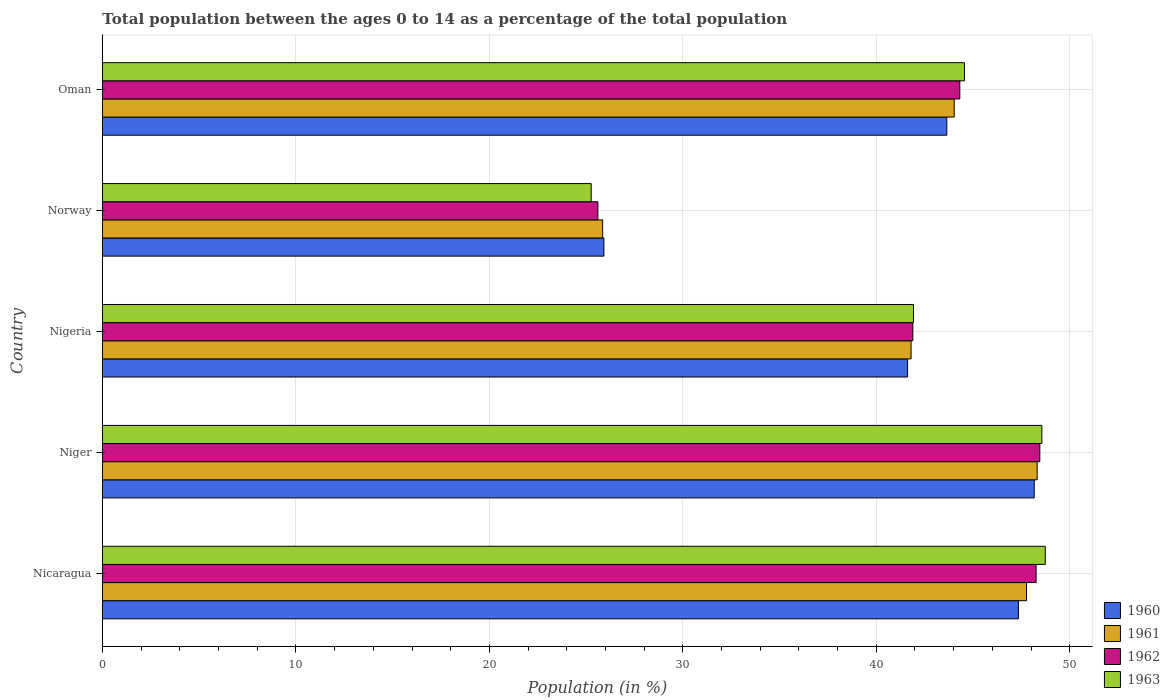How many different coloured bars are there?
Provide a short and direct response. 4. How many groups of bars are there?
Your response must be concise. 5. Are the number of bars per tick equal to the number of legend labels?
Your response must be concise. Yes. What is the label of the 2nd group of bars from the top?
Your answer should be very brief. Norway. What is the percentage of the population ages 0 to 14 in 1960 in Oman?
Ensure brevity in your answer.  43.65. Across all countries, what is the maximum percentage of the population ages 0 to 14 in 1963?
Give a very brief answer. 48.74. Across all countries, what is the minimum percentage of the population ages 0 to 14 in 1961?
Provide a succinct answer. 25.86. In which country was the percentage of the population ages 0 to 14 in 1963 maximum?
Give a very brief answer. Nicaragua. In which country was the percentage of the population ages 0 to 14 in 1962 minimum?
Offer a very short reply. Norway. What is the total percentage of the population ages 0 to 14 in 1960 in the graph?
Give a very brief answer. 206.69. What is the difference between the percentage of the population ages 0 to 14 in 1961 in Niger and that in Nigeria?
Offer a terse response. 6.52. What is the difference between the percentage of the population ages 0 to 14 in 1963 in Oman and the percentage of the population ages 0 to 14 in 1960 in Norway?
Ensure brevity in your answer.  18.64. What is the average percentage of the population ages 0 to 14 in 1961 per country?
Give a very brief answer. 41.55. What is the difference between the percentage of the population ages 0 to 14 in 1962 and percentage of the population ages 0 to 14 in 1961 in Oman?
Ensure brevity in your answer.  0.29. In how many countries, is the percentage of the population ages 0 to 14 in 1961 greater than 30 ?
Your answer should be very brief. 4. What is the ratio of the percentage of the population ages 0 to 14 in 1960 in Norway to that in Oman?
Provide a short and direct response. 0.59. Is the difference between the percentage of the population ages 0 to 14 in 1962 in Niger and Nigeria greater than the difference between the percentage of the population ages 0 to 14 in 1961 in Niger and Nigeria?
Ensure brevity in your answer.  Yes. What is the difference between the highest and the second highest percentage of the population ages 0 to 14 in 1963?
Provide a short and direct response. 0.18. What is the difference between the highest and the lowest percentage of the population ages 0 to 14 in 1962?
Give a very brief answer. 22.84. In how many countries, is the percentage of the population ages 0 to 14 in 1960 greater than the average percentage of the population ages 0 to 14 in 1960 taken over all countries?
Ensure brevity in your answer.  4. How many bars are there?
Offer a very short reply. 20. How many countries are there in the graph?
Give a very brief answer. 5. Does the graph contain any zero values?
Provide a short and direct response. No. Does the graph contain grids?
Your answer should be compact. Yes. How many legend labels are there?
Provide a succinct answer. 4. What is the title of the graph?
Ensure brevity in your answer.  Total population between the ages 0 to 14 as a percentage of the total population. What is the label or title of the X-axis?
Make the answer very short. Population (in %). What is the label or title of the Y-axis?
Your answer should be compact. Country. What is the Population (in %) of 1960 in Nicaragua?
Make the answer very short. 47.35. What is the Population (in %) of 1961 in Nicaragua?
Offer a terse response. 47.77. What is the Population (in %) in 1962 in Nicaragua?
Offer a terse response. 48.26. What is the Population (in %) in 1963 in Nicaragua?
Offer a terse response. 48.74. What is the Population (in %) in 1960 in Niger?
Offer a very short reply. 48.16. What is the Population (in %) in 1961 in Niger?
Give a very brief answer. 48.32. What is the Population (in %) in 1962 in Niger?
Offer a very short reply. 48.45. What is the Population (in %) in 1963 in Niger?
Offer a very short reply. 48.56. What is the Population (in %) of 1960 in Nigeria?
Provide a succinct answer. 41.62. What is the Population (in %) in 1961 in Nigeria?
Your answer should be compact. 41.8. What is the Population (in %) of 1962 in Nigeria?
Your answer should be very brief. 41.89. What is the Population (in %) in 1963 in Nigeria?
Give a very brief answer. 41.92. What is the Population (in %) of 1960 in Norway?
Make the answer very short. 25.92. What is the Population (in %) in 1961 in Norway?
Ensure brevity in your answer.  25.86. What is the Population (in %) in 1962 in Norway?
Provide a short and direct response. 25.61. What is the Population (in %) of 1963 in Norway?
Your response must be concise. 25.26. What is the Population (in %) in 1960 in Oman?
Ensure brevity in your answer.  43.65. What is the Population (in %) in 1961 in Oman?
Offer a terse response. 44.03. What is the Population (in %) in 1962 in Oman?
Offer a terse response. 44.32. What is the Population (in %) of 1963 in Oman?
Your answer should be compact. 44.56. Across all countries, what is the maximum Population (in %) in 1960?
Provide a short and direct response. 48.16. Across all countries, what is the maximum Population (in %) of 1961?
Offer a very short reply. 48.32. Across all countries, what is the maximum Population (in %) of 1962?
Provide a succinct answer. 48.45. Across all countries, what is the maximum Population (in %) in 1963?
Your response must be concise. 48.74. Across all countries, what is the minimum Population (in %) in 1960?
Provide a short and direct response. 25.92. Across all countries, what is the minimum Population (in %) of 1961?
Your answer should be very brief. 25.86. Across all countries, what is the minimum Population (in %) in 1962?
Keep it short and to the point. 25.61. Across all countries, what is the minimum Population (in %) of 1963?
Ensure brevity in your answer.  25.26. What is the total Population (in %) of 1960 in the graph?
Offer a very short reply. 206.69. What is the total Population (in %) in 1961 in the graph?
Give a very brief answer. 207.76. What is the total Population (in %) in 1962 in the graph?
Keep it short and to the point. 208.53. What is the total Population (in %) in 1963 in the graph?
Keep it short and to the point. 209.04. What is the difference between the Population (in %) of 1960 in Nicaragua and that in Niger?
Provide a short and direct response. -0.82. What is the difference between the Population (in %) of 1961 in Nicaragua and that in Niger?
Keep it short and to the point. -0.55. What is the difference between the Population (in %) of 1962 in Nicaragua and that in Niger?
Offer a terse response. -0.19. What is the difference between the Population (in %) in 1963 in Nicaragua and that in Niger?
Make the answer very short. 0.18. What is the difference between the Population (in %) in 1960 in Nicaragua and that in Nigeria?
Provide a short and direct response. 5.73. What is the difference between the Population (in %) of 1961 in Nicaragua and that in Nigeria?
Offer a very short reply. 5.97. What is the difference between the Population (in %) in 1962 in Nicaragua and that in Nigeria?
Offer a very short reply. 6.37. What is the difference between the Population (in %) of 1963 in Nicaragua and that in Nigeria?
Offer a terse response. 6.81. What is the difference between the Population (in %) in 1960 in Nicaragua and that in Norway?
Provide a succinct answer. 21.43. What is the difference between the Population (in %) in 1961 in Nicaragua and that in Norway?
Keep it short and to the point. 21.91. What is the difference between the Population (in %) of 1962 in Nicaragua and that in Norway?
Your response must be concise. 22.65. What is the difference between the Population (in %) in 1963 in Nicaragua and that in Norway?
Your answer should be compact. 23.47. What is the difference between the Population (in %) in 1960 in Nicaragua and that in Oman?
Offer a terse response. 3.7. What is the difference between the Population (in %) of 1961 in Nicaragua and that in Oman?
Your answer should be very brief. 3.74. What is the difference between the Population (in %) of 1962 in Nicaragua and that in Oman?
Your answer should be very brief. 3.94. What is the difference between the Population (in %) in 1963 in Nicaragua and that in Oman?
Ensure brevity in your answer.  4.18. What is the difference between the Population (in %) of 1960 in Niger and that in Nigeria?
Provide a short and direct response. 6.54. What is the difference between the Population (in %) in 1961 in Niger and that in Nigeria?
Offer a terse response. 6.52. What is the difference between the Population (in %) in 1962 in Niger and that in Nigeria?
Give a very brief answer. 6.57. What is the difference between the Population (in %) in 1963 in Niger and that in Nigeria?
Keep it short and to the point. 6.64. What is the difference between the Population (in %) in 1960 in Niger and that in Norway?
Ensure brevity in your answer.  22.24. What is the difference between the Population (in %) of 1961 in Niger and that in Norway?
Your response must be concise. 22.46. What is the difference between the Population (in %) of 1962 in Niger and that in Norway?
Offer a terse response. 22.84. What is the difference between the Population (in %) in 1963 in Niger and that in Norway?
Offer a very short reply. 23.3. What is the difference between the Population (in %) in 1960 in Niger and that in Oman?
Give a very brief answer. 4.52. What is the difference between the Population (in %) of 1961 in Niger and that in Oman?
Provide a short and direct response. 4.29. What is the difference between the Population (in %) in 1962 in Niger and that in Oman?
Provide a succinct answer. 4.14. What is the difference between the Population (in %) of 1963 in Niger and that in Oman?
Offer a very short reply. 4. What is the difference between the Population (in %) of 1960 in Nigeria and that in Norway?
Offer a terse response. 15.7. What is the difference between the Population (in %) of 1961 in Nigeria and that in Norway?
Offer a terse response. 15.94. What is the difference between the Population (in %) in 1962 in Nigeria and that in Norway?
Make the answer very short. 16.28. What is the difference between the Population (in %) of 1963 in Nigeria and that in Norway?
Provide a succinct answer. 16.66. What is the difference between the Population (in %) in 1960 in Nigeria and that in Oman?
Your answer should be very brief. -2.03. What is the difference between the Population (in %) in 1961 in Nigeria and that in Oman?
Your answer should be compact. -2.23. What is the difference between the Population (in %) in 1962 in Nigeria and that in Oman?
Make the answer very short. -2.43. What is the difference between the Population (in %) in 1963 in Nigeria and that in Oman?
Offer a terse response. -2.63. What is the difference between the Population (in %) of 1960 in Norway and that in Oman?
Ensure brevity in your answer.  -17.73. What is the difference between the Population (in %) of 1961 in Norway and that in Oman?
Your answer should be compact. -18.17. What is the difference between the Population (in %) of 1962 in Norway and that in Oman?
Make the answer very short. -18.71. What is the difference between the Population (in %) of 1963 in Norway and that in Oman?
Offer a terse response. -19.3. What is the difference between the Population (in %) of 1960 in Nicaragua and the Population (in %) of 1961 in Niger?
Keep it short and to the point. -0.97. What is the difference between the Population (in %) of 1960 in Nicaragua and the Population (in %) of 1962 in Niger?
Your response must be concise. -1.11. What is the difference between the Population (in %) in 1960 in Nicaragua and the Population (in %) in 1963 in Niger?
Your response must be concise. -1.21. What is the difference between the Population (in %) in 1961 in Nicaragua and the Population (in %) in 1962 in Niger?
Your answer should be very brief. -0.69. What is the difference between the Population (in %) of 1961 in Nicaragua and the Population (in %) of 1963 in Niger?
Your response must be concise. -0.79. What is the difference between the Population (in %) of 1962 in Nicaragua and the Population (in %) of 1963 in Niger?
Your response must be concise. -0.3. What is the difference between the Population (in %) in 1960 in Nicaragua and the Population (in %) in 1961 in Nigeria?
Ensure brevity in your answer.  5.55. What is the difference between the Population (in %) in 1960 in Nicaragua and the Population (in %) in 1962 in Nigeria?
Keep it short and to the point. 5.46. What is the difference between the Population (in %) in 1960 in Nicaragua and the Population (in %) in 1963 in Nigeria?
Provide a short and direct response. 5.42. What is the difference between the Population (in %) of 1961 in Nicaragua and the Population (in %) of 1962 in Nigeria?
Provide a short and direct response. 5.88. What is the difference between the Population (in %) of 1961 in Nicaragua and the Population (in %) of 1963 in Nigeria?
Ensure brevity in your answer.  5.84. What is the difference between the Population (in %) of 1962 in Nicaragua and the Population (in %) of 1963 in Nigeria?
Your answer should be very brief. 6.34. What is the difference between the Population (in %) in 1960 in Nicaragua and the Population (in %) in 1961 in Norway?
Keep it short and to the point. 21.49. What is the difference between the Population (in %) of 1960 in Nicaragua and the Population (in %) of 1962 in Norway?
Offer a terse response. 21.74. What is the difference between the Population (in %) in 1960 in Nicaragua and the Population (in %) in 1963 in Norway?
Provide a succinct answer. 22.08. What is the difference between the Population (in %) in 1961 in Nicaragua and the Population (in %) in 1962 in Norway?
Keep it short and to the point. 22.16. What is the difference between the Population (in %) of 1961 in Nicaragua and the Population (in %) of 1963 in Norway?
Provide a short and direct response. 22.5. What is the difference between the Population (in %) of 1962 in Nicaragua and the Population (in %) of 1963 in Norway?
Provide a succinct answer. 23. What is the difference between the Population (in %) of 1960 in Nicaragua and the Population (in %) of 1961 in Oman?
Offer a very short reply. 3.32. What is the difference between the Population (in %) of 1960 in Nicaragua and the Population (in %) of 1962 in Oman?
Your response must be concise. 3.03. What is the difference between the Population (in %) of 1960 in Nicaragua and the Population (in %) of 1963 in Oman?
Ensure brevity in your answer.  2.79. What is the difference between the Population (in %) of 1961 in Nicaragua and the Population (in %) of 1962 in Oman?
Ensure brevity in your answer.  3.45. What is the difference between the Population (in %) of 1961 in Nicaragua and the Population (in %) of 1963 in Oman?
Your response must be concise. 3.21. What is the difference between the Population (in %) of 1962 in Nicaragua and the Population (in %) of 1963 in Oman?
Your answer should be compact. 3.7. What is the difference between the Population (in %) of 1960 in Niger and the Population (in %) of 1961 in Nigeria?
Your answer should be compact. 6.37. What is the difference between the Population (in %) in 1960 in Niger and the Population (in %) in 1962 in Nigeria?
Make the answer very short. 6.28. What is the difference between the Population (in %) in 1960 in Niger and the Population (in %) in 1963 in Nigeria?
Provide a succinct answer. 6.24. What is the difference between the Population (in %) of 1961 in Niger and the Population (in %) of 1962 in Nigeria?
Ensure brevity in your answer.  6.43. What is the difference between the Population (in %) of 1961 in Niger and the Population (in %) of 1963 in Nigeria?
Ensure brevity in your answer.  6.39. What is the difference between the Population (in %) of 1962 in Niger and the Population (in %) of 1963 in Nigeria?
Ensure brevity in your answer.  6.53. What is the difference between the Population (in %) in 1960 in Niger and the Population (in %) in 1961 in Norway?
Provide a short and direct response. 22.31. What is the difference between the Population (in %) in 1960 in Niger and the Population (in %) in 1962 in Norway?
Provide a succinct answer. 22.55. What is the difference between the Population (in %) of 1960 in Niger and the Population (in %) of 1963 in Norway?
Give a very brief answer. 22.9. What is the difference between the Population (in %) in 1961 in Niger and the Population (in %) in 1962 in Norway?
Ensure brevity in your answer.  22.71. What is the difference between the Population (in %) in 1961 in Niger and the Population (in %) in 1963 in Norway?
Give a very brief answer. 23.05. What is the difference between the Population (in %) in 1962 in Niger and the Population (in %) in 1963 in Norway?
Your answer should be very brief. 23.19. What is the difference between the Population (in %) of 1960 in Niger and the Population (in %) of 1961 in Oman?
Your answer should be compact. 4.14. What is the difference between the Population (in %) of 1960 in Niger and the Population (in %) of 1962 in Oman?
Provide a succinct answer. 3.85. What is the difference between the Population (in %) in 1960 in Niger and the Population (in %) in 1963 in Oman?
Give a very brief answer. 3.61. What is the difference between the Population (in %) in 1961 in Niger and the Population (in %) in 1962 in Oman?
Offer a very short reply. 4. What is the difference between the Population (in %) in 1961 in Niger and the Population (in %) in 1963 in Oman?
Your response must be concise. 3.76. What is the difference between the Population (in %) of 1962 in Niger and the Population (in %) of 1963 in Oman?
Your answer should be very brief. 3.9. What is the difference between the Population (in %) of 1960 in Nigeria and the Population (in %) of 1961 in Norway?
Provide a succinct answer. 15.76. What is the difference between the Population (in %) in 1960 in Nigeria and the Population (in %) in 1962 in Norway?
Your answer should be compact. 16.01. What is the difference between the Population (in %) in 1960 in Nigeria and the Population (in %) in 1963 in Norway?
Your answer should be very brief. 16.36. What is the difference between the Population (in %) in 1961 in Nigeria and the Population (in %) in 1962 in Norway?
Ensure brevity in your answer.  16.19. What is the difference between the Population (in %) in 1961 in Nigeria and the Population (in %) in 1963 in Norway?
Give a very brief answer. 16.54. What is the difference between the Population (in %) of 1962 in Nigeria and the Population (in %) of 1963 in Norway?
Make the answer very short. 16.63. What is the difference between the Population (in %) in 1960 in Nigeria and the Population (in %) in 1961 in Oman?
Offer a very short reply. -2.41. What is the difference between the Population (in %) in 1960 in Nigeria and the Population (in %) in 1962 in Oman?
Give a very brief answer. -2.7. What is the difference between the Population (in %) in 1960 in Nigeria and the Population (in %) in 1963 in Oman?
Make the answer very short. -2.94. What is the difference between the Population (in %) in 1961 in Nigeria and the Population (in %) in 1962 in Oman?
Provide a short and direct response. -2.52. What is the difference between the Population (in %) of 1961 in Nigeria and the Population (in %) of 1963 in Oman?
Keep it short and to the point. -2.76. What is the difference between the Population (in %) of 1962 in Nigeria and the Population (in %) of 1963 in Oman?
Your answer should be compact. -2.67. What is the difference between the Population (in %) of 1960 in Norway and the Population (in %) of 1961 in Oman?
Make the answer very short. -18.11. What is the difference between the Population (in %) of 1960 in Norway and the Population (in %) of 1962 in Oman?
Provide a succinct answer. -18.4. What is the difference between the Population (in %) in 1960 in Norway and the Population (in %) in 1963 in Oman?
Give a very brief answer. -18.64. What is the difference between the Population (in %) of 1961 in Norway and the Population (in %) of 1962 in Oman?
Keep it short and to the point. -18.46. What is the difference between the Population (in %) of 1961 in Norway and the Population (in %) of 1963 in Oman?
Provide a short and direct response. -18.7. What is the difference between the Population (in %) in 1962 in Norway and the Population (in %) in 1963 in Oman?
Your response must be concise. -18.95. What is the average Population (in %) in 1960 per country?
Give a very brief answer. 41.34. What is the average Population (in %) of 1961 per country?
Offer a very short reply. 41.55. What is the average Population (in %) of 1962 per country?
Provide a short and direct response. 41.71. What is the average Population (in %) in 1963 per country?
Offer a very short reply. 41.81. What is the difference between the Population (in %) in 1960 and Population (in %) in 1961 in Nicaragua?
Make the answer very short. -0.42. What is the difference between the Population (in %) in 1960 and Population (in %) in 1962 in Nicaragua?
Your answer should be very brief. -0.91. What is the difference between the Population (in %) in 1960 and Population (in %) in 1963 in Nicaragua?
Ensure brevity in your answer.  -1.39. What is the difference between the Population (in %) of 1961 and Population (in %) of 1962 in Nicaragua?
Ensure brevity in your answer.  -0.49. What is the difference between the Population (in %) of 1961 and Population (in %) of 1963 in Nicaragua?
Your answer should be very brief. -0.97. What is the difference between the Population (in %) in 1962 and Population (in %) in 1963 in Nicaragua?
Give a very brief answer. -0.48. What is the difference between the Population (in %) of 1960 and Population (in %) of 1961 in Niger?
Give a very brief answer. -0.15. What is the difference between the Population (in %) in 1960 and Population (in %) in 1962 in Niger?
Offer a terse response. -0.29. What is the difference between the Population (in %) in 1960 and Population (in %) in 1963 in Niger?
Offer a very short reply. -0.39. What is the difference between the Population (in %) of 1961 and Population (in %) of 1962 in Niger?
Ensure brevity in your answer.  -0.14. What is the difference between the Population (in %) in 1961 and Population (in %) in 1963 in Niger?
Ensure brevity in your answer.  -0.24. What is the difference between the Population (in %) of 1962 and Population (in %) of 1963 in Niger?
Make the answer very short. -0.1. What is the difference between the Population (in %) of 1960 and Population (in %) of 1961 in Nigeria?
Your answer should be very brief. -0.18. What is the difference between the Population (in %) in 1960 and Population (in %) in 1962 in Nigeria?
Give a very brief answer. -0.27. What is the difference between the Population (in %) in 1960 and Population (in %) in 1963 in Nigeria?
Your answer should be compact. -0.3. What is the difference between the Population (in %) in 1961 and Population (in %) in 1962 in Nigeria?
Offer a terse response. -0.09. What is the difference between the Population (in %) in 1961 and Population (in %) in 1963 in Nigeria?
Your answer should be compact. -0.12. What is the difference between the Population (in %) in 1962 and Population (in %) in 1963 in Nigeria?
Offer a terse response. -0.03. What is the difference between the Population (in %) of 1960 and Population (in %) of 1961 in Norway?
Offer a terse response. 0.06. What is the difference between the Population (in %) of 1960 and Population (in %) of 1962 in Norway?
Ensure brevity in your answer.  0.31. What is the difference between the Population (in %) of 1960 and Population (in %) of 1963 in Norway?
Offer a very short reply. 0.66. What is the difference between the Population (in %) of 1961 and Population (in %) of 1962 in Norway?
Offer a terse response. 0.25. What is the difference between the Population (in %) of 1961 and Population (in %) of 1963 in Norway?
Your answer should be very brief. 0.59. What is the difference between the Population (in %) of 1962 and Population (in %) of 1963 in Norway?
Provide a short and direct response. 0.35. What is the difference between the Population (in %) in 1960 and Population (in %) in 1961 in Oman?
Your answer should be very brief. -0.38. What is the difference between the Population (in %) in 1960 and Population (in %) in 1962 in Oman?
Offer a terse response. -0.67. What is the difference between the Population (in %) of 1960 and Population (in %) of 1963 in Oman?
Provide a short and direct response. -0.91. What is the difference between the Population (in %) of 1961 and Population (in %) of 1962 in Oman?
Keep it short and to the point. -0.29. What is the difference between the Population (in %) of 1961 and Population (in %) of 1963 in Oman?
Ensure brevity in your answer.  -0.53. What is the difference between the Population (in %) of 1962 and Population (in %) of 1963 in Oman?
Offer a very short reply. -0.24. What is the ratio of the Population (in %) of 1960 in Nicaragua to that in Niger?
Ensure brevity in your answer.  0.98. What is the ratio of the Population (in %) of 1961 in Nicaragua to that in Niger?
Keep it short and to the point. 0.99. What is the ratio of the Population (in %) of 1962 in Nicaragua to that in Niger?
Your answer should be very brief. 1. What is the ratio of the Population (in %) of 1960 in Nicaragua to that in Nigeria?
Your answer should be compact. 1.14. What is the ratio of the Population (in %) in 1961 in Nicaragua to that in Nigeria?
Give a very brief answer. 1.14. What is the ratio of the Population (in %) in 1962 in Nicaragua to that in Nigeria?
Keep it short and to the point. 1.15. What is the ratio of the Population (in %) in 1963 in Nicaragua to that in Nigeria?
Offer a very short reply. 1.16. What is the ratio of the Population (in %) in 1960 in Nicaragua to that in Norway?
Your response must be concise. 1.83. What is the ratio of the Population (in %) in 1961 in Nicaragua to that in Norway?
Offer a very short reply. 1.85. What is the ratio of the Population (in %) in 1962 in Nicaragua to that in Norway?
Provide a succinct answer. 1.88. What is the ratio of the Population (in %) of 1963 in Nicaragua to that in Norway?
Ensure brevity in your answer.  1.93. What is the ratio of the Population (in %) in 1960 in Nicaragua to that in Oman?
Give a very brief answer. 1.08. What is the ratio of the Population (in %) of 1961 in Nicaragua to that in Oman?
Offer a terse response. 1.08. What is the ratio of the Population (in %) of 1962 in Nicaragua to that in Oman?
Ensure brevity in your answer.  1.09. What is the ratio of the Population (in %) in 1963 in Nicaragua to that in Oman?
Ensure brevity in your answer.  1.09. What is the ratio of the Population (in %) in 1960 in Niger to that in Nigeria?
Your answer should be very brief. 1.16. What is the ratio of the Population (in %) of 1961 in Niger to that in Nigeria?
Offer a terse response. 1.16. What is the ratio of the Population (in %) in 1962 in Niger to that in Nigeria?
Offer a very short reply. 1.16. What is the ratio of the Population (in %) in 1963 in Niger to that in Nigeria?
Your answer should be compact. 1.16. What is the ratio of the Population (in %) in 1960 in Niger to that in Norway?
Your answer should be compact. 1.86. What is the ratio of the Population (in %) in 1961 in Niger to that in Norway?
Provide a succinct answer. 1.87. What is the ratio of the Population (in %) in 1962 in Niger to that in Norway?
Make the answer very short. 1.89. What is the ratio of the Population (in %) in 1963 in Niger to that in Norway?
Provide a succinct answer. 1.92. What is the ratio of the Population (in %) of 1960 in Niger to that in Oman?
Keep it short and to the point. 1.1. What is the ratio of the Population (in %) of 1961 in Niger to that in Oman?
Give a very brief answer. 1.1. What is the ratio of the Population (in %) in 1962 in Niger to that in Oman?
Make the answer very short. 1.09. What is the ratio of the Population (in %) in 1963 in Niger to that in Oman?
Give a very brief answer. 1.09. What is the ratio of the Population (in %) of 1960 in Nigeria to that in Norway?
Your response must be concise. 1.61. What is the ratio of the Population (in %) of 1961 in Nigeria to that in Norway?
Your answer should be compact. 1.62. What is the ratio of the Population (in %) of 1962 in Nigeria to that in Norway?
Ensure brevity in your answer.  1.64. What is the ratio of the Population (in %) of 1963 in Nigeria to that in Norway?
Give a very brief answer. 1.66. What is the ratio of the Population (in %) of 1960 in Nigeria to that in Oman?
Keep it short and to the point. 0.95. What is the ratio of the Population (in %) of 1961 in Nigeria to that in Oman?
Your response must be concise. 0.95. What is the ratio of the Population (in %) of 1962 in Nigeria to that in Oman?
Provide a short and direct response. 0.95. What is the ratio of the Population (in %) of 1963 in Nigeria to that in Oman?
Make the answer very short. 0.94. What is the ratio of the Population (in %) in 1960 in Norway to that in Oman?
Your answer should be compact. 0.59. What is the ratio of the Population (in %) of 1961 in Norway to that in Oman?
Make the answer very short. 0.59. What is the ratio of the Population (in %) in 1962 in Norway to that in Oman?
Offer a very short reply. 0.58. What is the ratio of the Population (in %) of 1963 in Norway to that in Oman?
Keep it short and to the point. 0.57. What is the difference between the highest and the second highest Population (in %) of 1960?
Your answer should be compact. 0.82. What is the difference between the highest and the second highest Population (in %) of 1961?
Give a very brief answer. 0.55. What is the difference between the highest and the second highest Population (in %) of 1962?
Provide a short and direct response. 0.19. What is the difference between the highest and the second highest Population (in %) in 1963?
Offer a very short reply. 0.18. What is the difference between the highest and the lowest Population (in %) of 1960?
Ensure brevity in your answer.  22.24. What is the difference between the highest and the lowest Population (in %) of 1961?
Your answer should be very brief. 22.46. What is the difference between the highest and the lowest Population (in %) in 1962?
Offer a very short reply. 22.84. What is the difference between the highest and the lowest Population (in %) in 1963?
Ensure brevity in your answer.  23.47. 